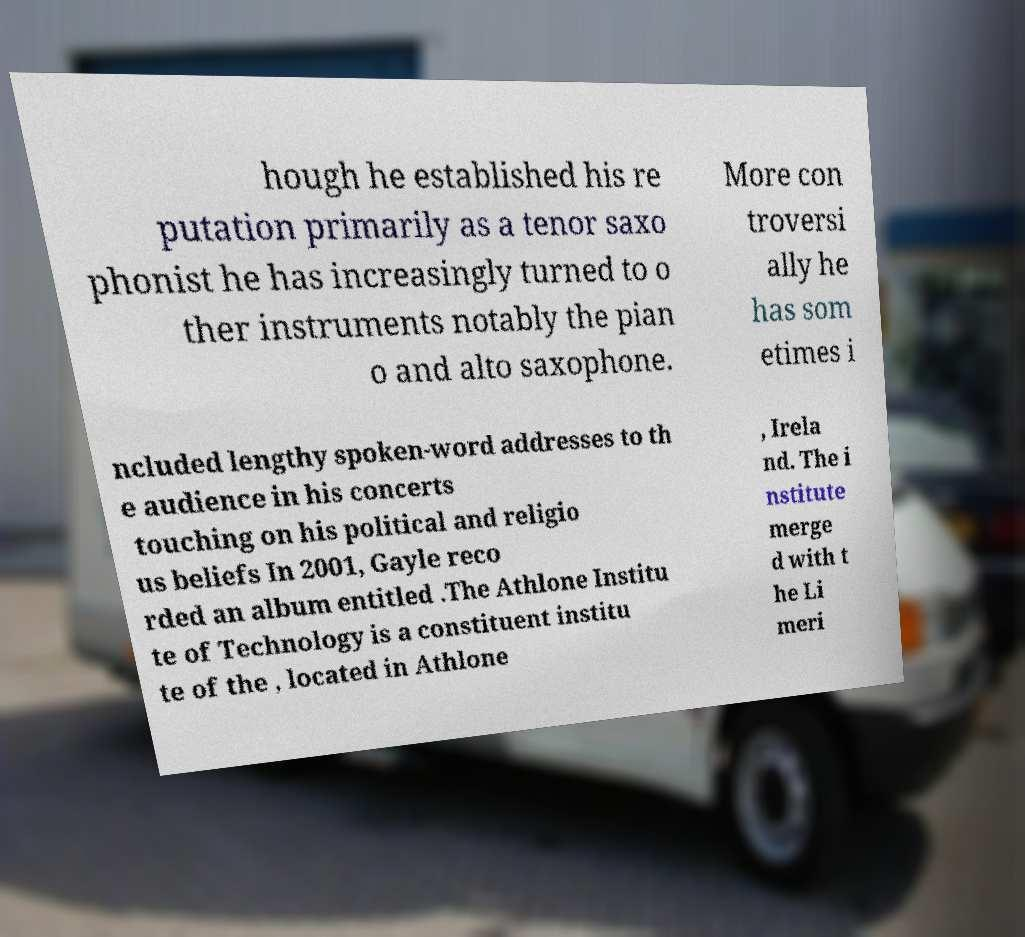Can you read and provide the text displayed in the image?This photo seems to have some interesting text. Can you extract and type it out for me? hough he established his re putation primarily as a tenor saxo phonist he has increasingly turned to o ther instruments notably the pian o and alto saxophone. More con troversi ally he has som etimes i ncluded lengthy spoken-word addresses to th e audience in his concerts touching on his political and religio us beliefs In 2001, Gayle reco rded an album entitled .The Athlone Institu te of Technology is a constituent institu te of the , located in Athlone , Irela nd. The i nstitute merge d with t he Li meri 